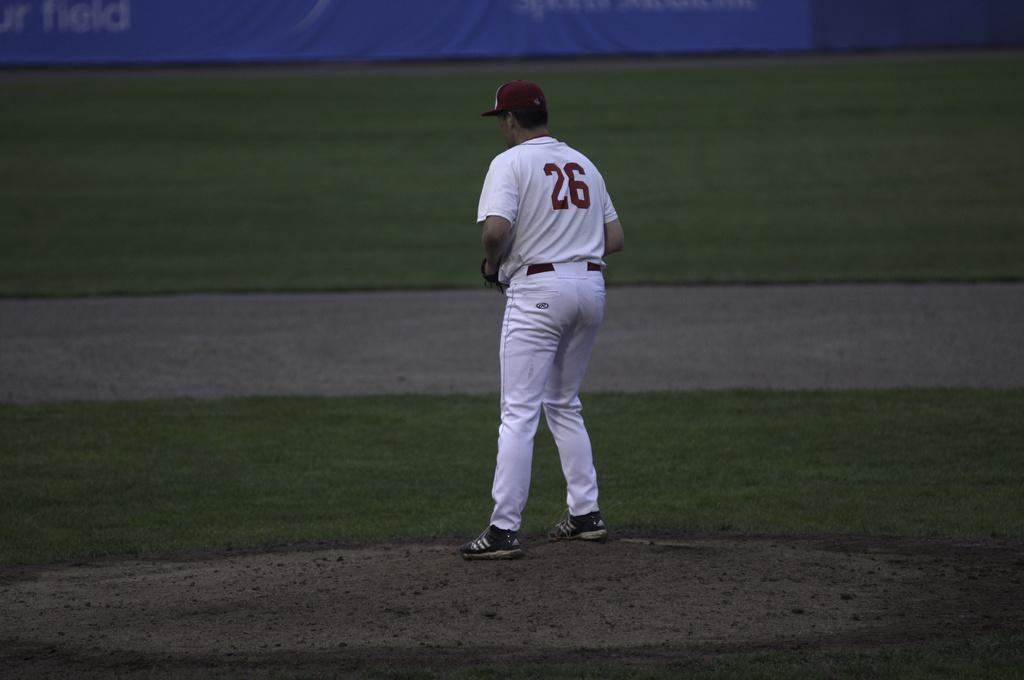<image>
Share a concise interpretation of the image provided. Man wearing a white jersey with a number 26 on it. 